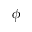<formula> <loc_0><loc_0><loc_500><loc_500>\phi</formula> 